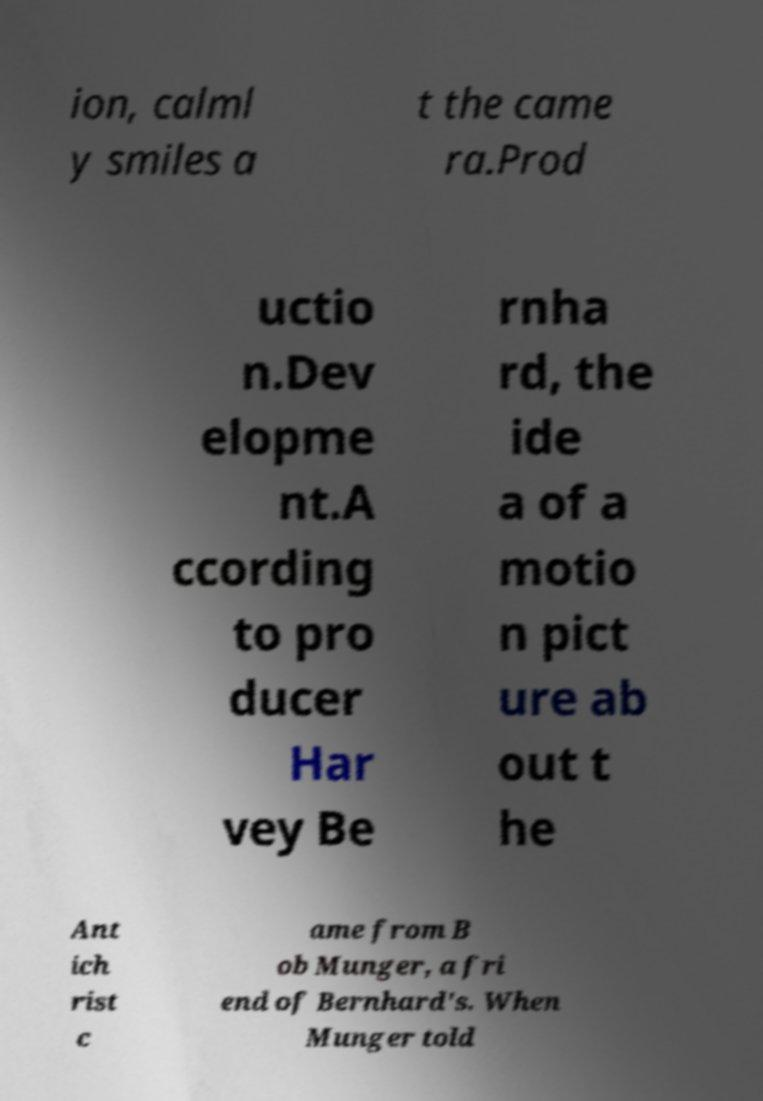For documentation purposes, I need the text within this image transcribed. Could you provide that? ion, calml y smiles a t the came ra.Prod uctio n.Dev elopme nt.A ccording to pro ducer Har vey Be rnha rd, the ide a of a motio n pict ure ab out t he Ant ich rist c ame from B ob Munger, a fri end of Bernhard's. When Munger told 